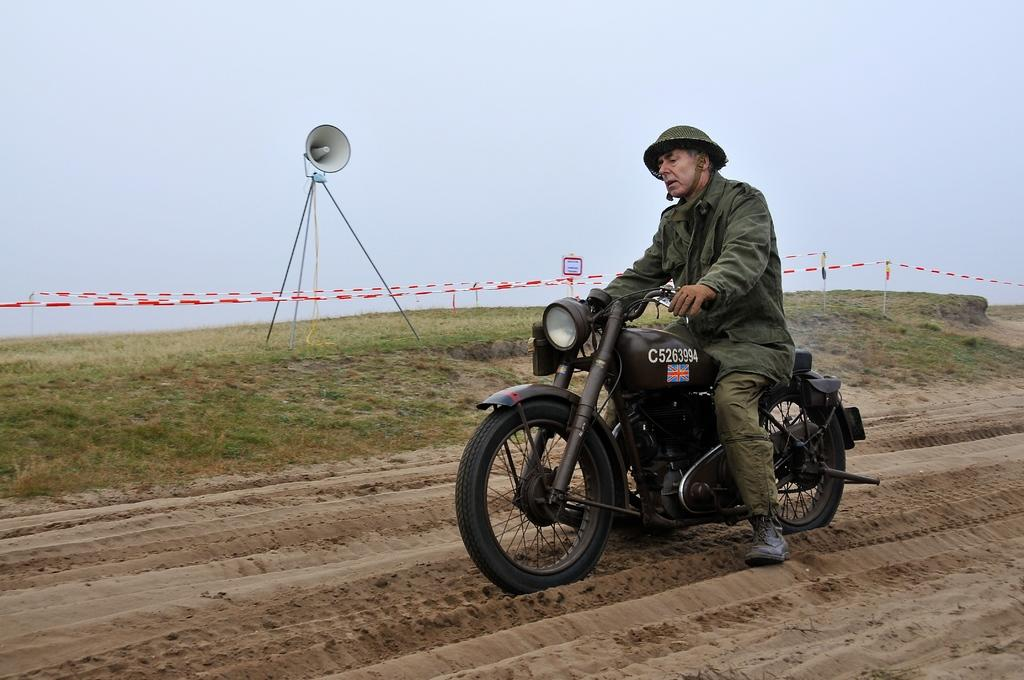What is the man in the image doing? The man is riding a bike in the image. What is the condition of the bike and its surroundings? The bike is in the mud, and the man is riding it. What safety gear is the man wearing? The man is wearing a helmet. What can be seen in the background of the image? There is land, a speaker, and the sky visible in the background of the image. Can you tell me how many cats are sitting on the art piece in the image? There are no cats or art pieces present in the image. 